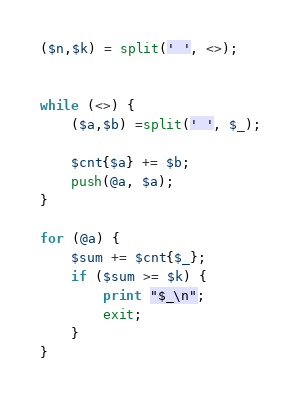Convert code to text. <code><loc_0><loc_0><loc_500><loc_500><_Perl_>($n,$k) = split(' ', <>);


while (<>) {
    ($a,$b) =split(' ', $_);

    $cnt{$a} += $b;
    push(@a, $a);
}

for (@a) {
    $sum += $cnt{$_};
    if ($sum >= $k) {
        print "$_\n";
        exit;
    }
}</code> 